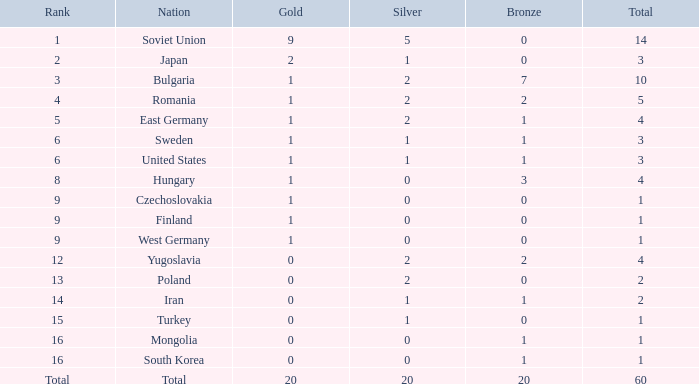What is the combined amount of bronzes holding silvers more than 5 and golds fewer than 20? None. 